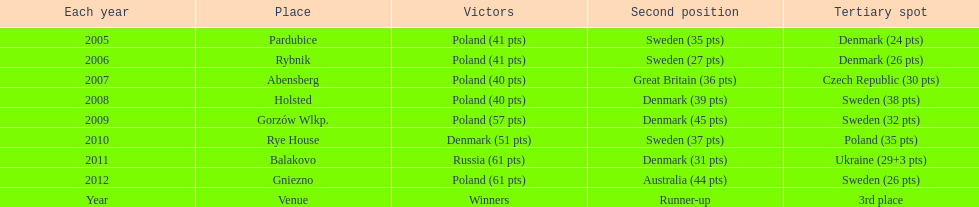After 2008 how many points total were scored by winners? 230. 